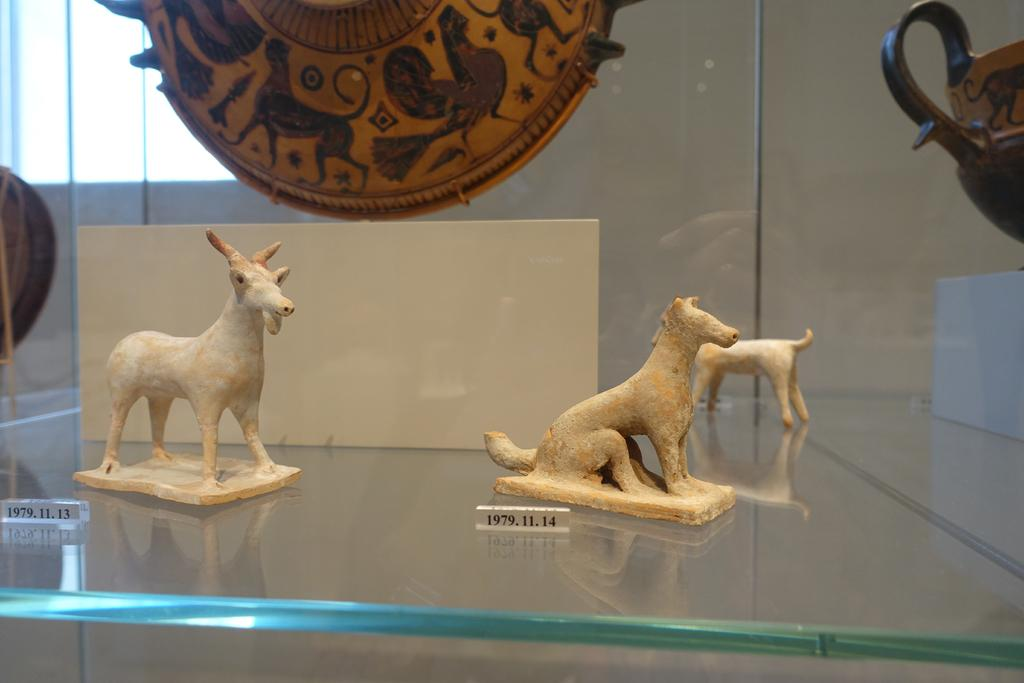What type of objects can be seen in the image? There are small sculptures of animals and boards with numbers in the image. What material is the wooden object made of? The wooden object is made of wood. What is the suggested purpose of the wooden object? It is suggested that the wooden object might be a glass rack. What type of education does the manager of the glass rack have? There is no manager present in the image, and therefore no information about their education can be provided. What rhythm is the wooden object following in the image? The wooden object is not following any rhythm in the image; it is a static object. 